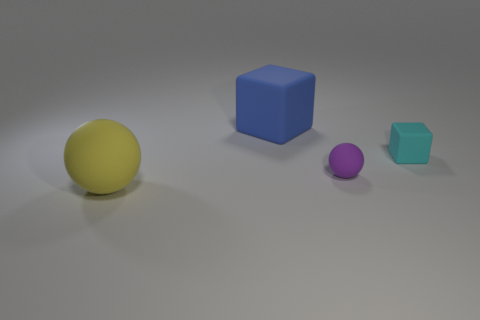Add 3 purple matte balls. How many objects exist? 7 Add 4 tiny spheres. How many tiny spheres are left? 5 Add 4 big yellow rubber balls. How many big yellow rubber balls exist? 5 Subtract 1 yellow spheres. How many objects are left? 3 Subtract all big blue matte objects. Subtract all yellow matte things. How many objects are left? 2 